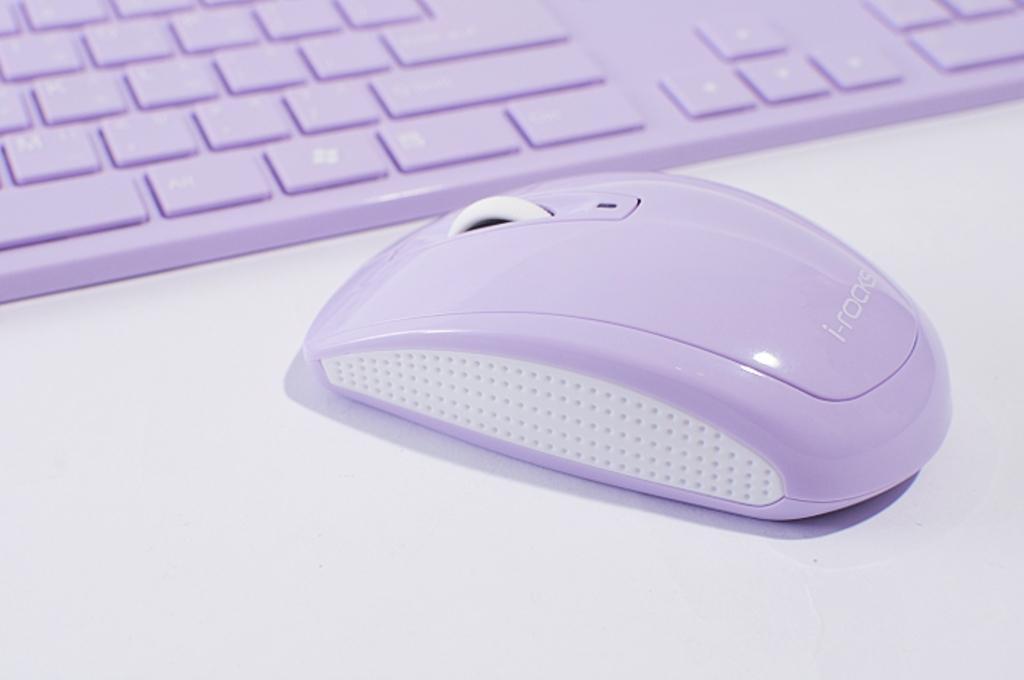Can you describe this image briefly? In this image I can see a computer mouse and a keyboard on a white color surface. 